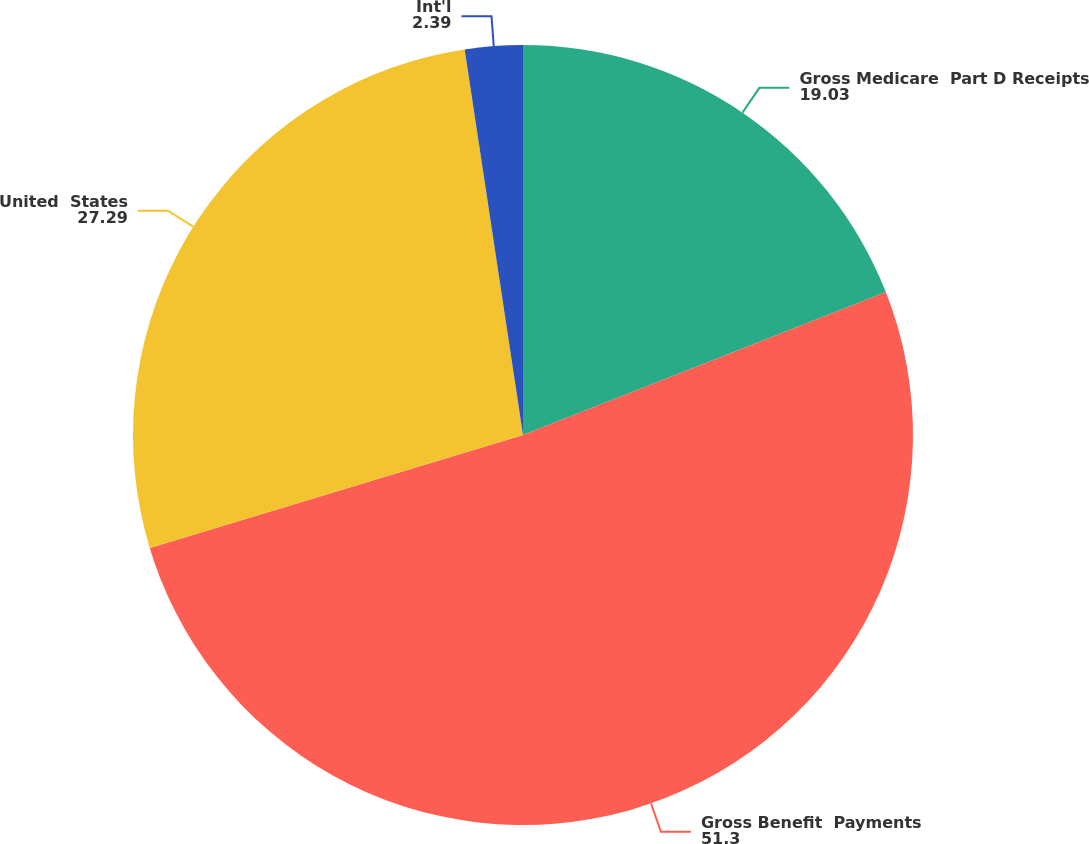Convert chart to OTSL. <chart><loc_0><loc_0><loc_500><loc_500><pie_chart><fcel>Gross Medicare  Part D Receipts<fcel>Gross Benefit  Payments<fcel>United  States<fcel>Int'l<nl><fcel>19.03%<fcel>51.3%<fcel>27.29%<fcel>2.39%<nl></chart> 